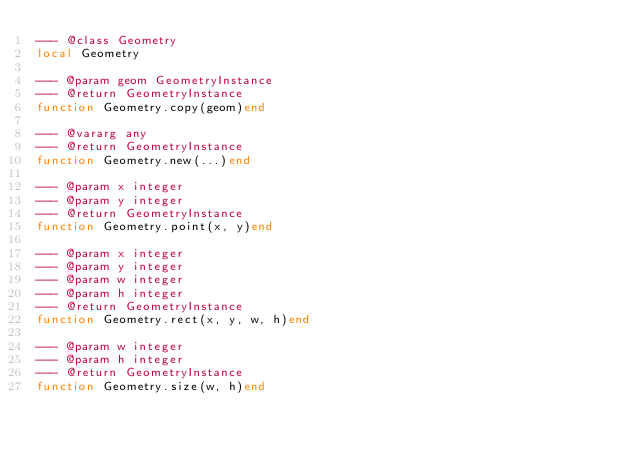Convert code to text. <code><loc_0><loc_0><loc_500><loc_500><_Lua_>--- @class Geometry
local Geometry

--- @param geom GeometryInstance
--- @return GeometryInstance
function Geometry.copy(geom)end

--- @vararg any
--- @return GeometryInstance
function Geometry.new(...)end

--- @param x integer
--- @param y integer
--- @return GeometryInstance
function Geometry.point(x, y)end

--- @param x integer
--- @param y integer
--- @param w integer
--- @param h integer
--- @return GeometryInstance
function Geometry.rect(x, y, w, h)end

--- @param w integer
--- @param h integer
--- @return GeometryInstance
function Geometry.size(w, h)end
</code> 